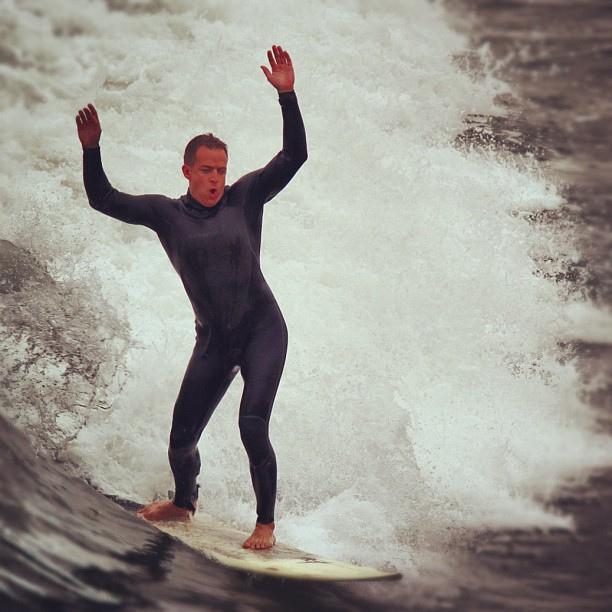Is the person a good surfer?
Quick response, please. Yes. How deep is the water?
Concise answer only. Deep. How many hands are in the air?
Answer briefly. 2. Is the woman wearing shoes?
Be succinct. No. Is this a man?
Short answer required. Yes. What is white in the water?
Concise answer only. Waves. Is this an image from a viewpoint close to the surfer?
Write a very short answer. Yes. Which foot is closest to the front of the surfboard?
Quick response, please. Left. 